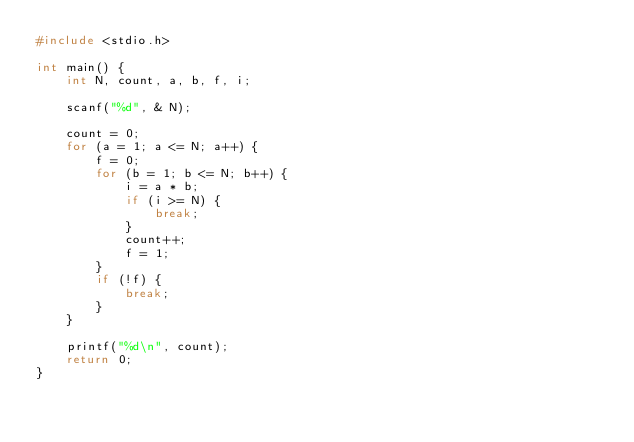Convert code to text. <code><loc_0><loc_0><loc_500><loc_500><_C_>#include <stdio.h>

int main() {
    int N, count, a, b, f, i;

    scanf("%d", & N);

    count = 0;
    for (a = 1; a <= N; a++) {
        f = 0;
        for (b = 1; b <= N; b++) {
            i = a * b;
            if (i >= N) {
                break;
            }
            count++;
            f = 1;
        }
        if (!f) {
            break;
        }
    }

    printf("%d\n", count);
    return 0;
}</code> 